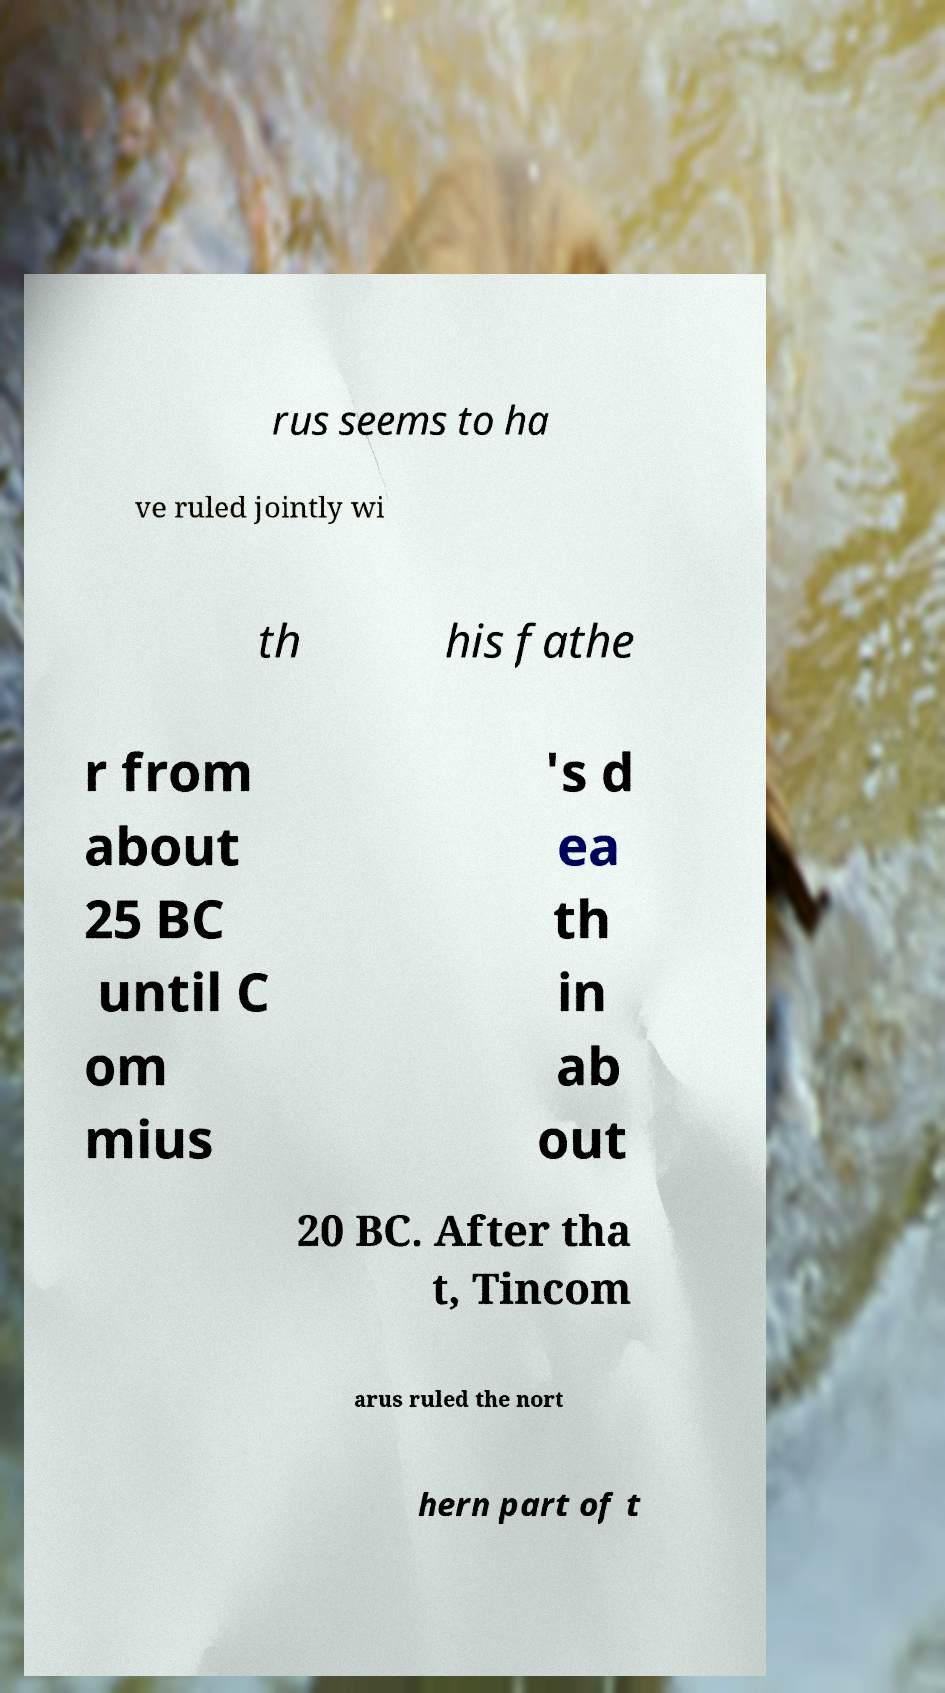Please identify and transcribe the text found in this image. rus seems to ha ve ruled jointly wi th his fathe r from about 25 BC until C om mius 's d ea th in ab out 20 BC. After tha t, Tincom arus ruled the nort hern part of t 